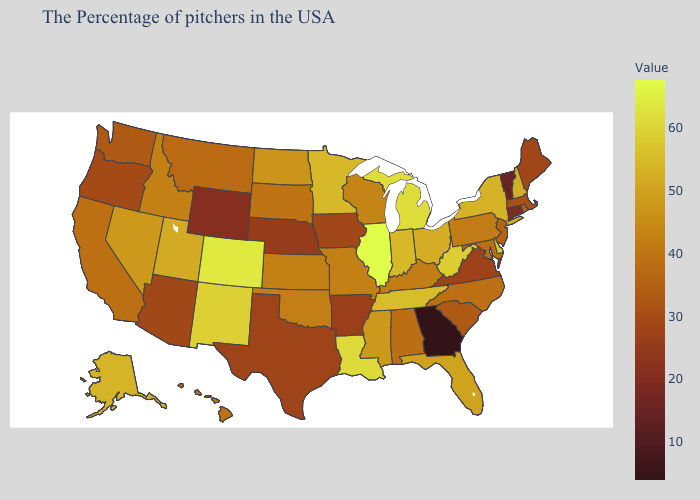Does Virginia have a higher value than Maryland?
Short answer required. No. Does Virginia have the lowest value in the USA?
Short answer required. No. Is the legend a continuous bar?
Concise answer only. Yes. Which states have the lowest value in the USA?
Answer briefly. Georgia. 